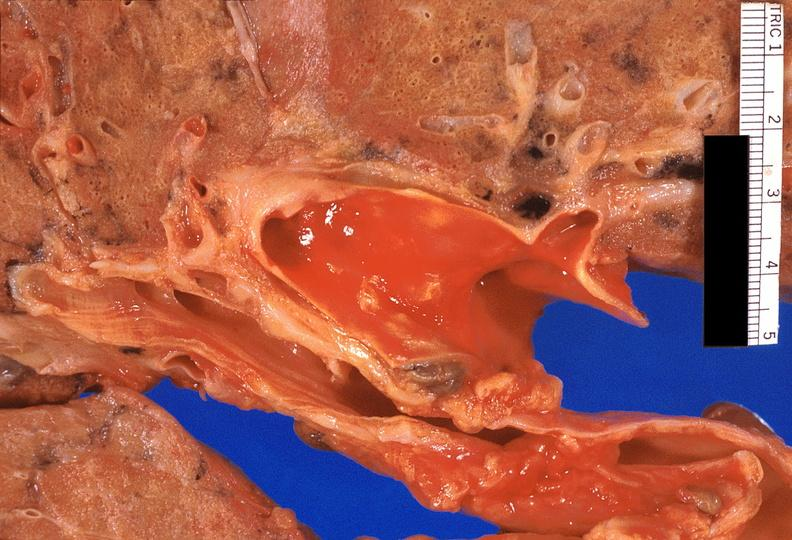does this image show lung, pulmonary fibrosis and atherosclerosis of pulmonary artery?
Answer the question using a single word or phrase. Yes 